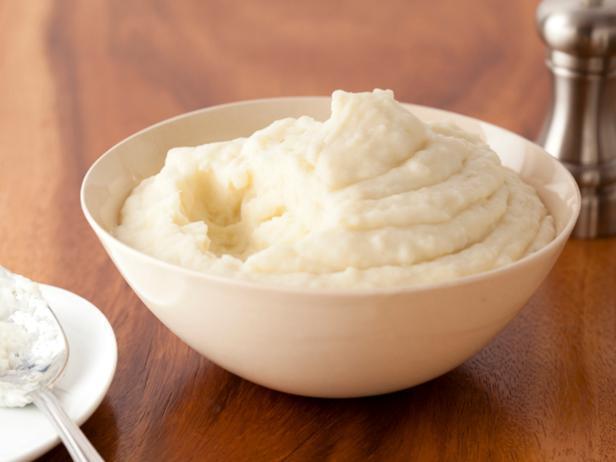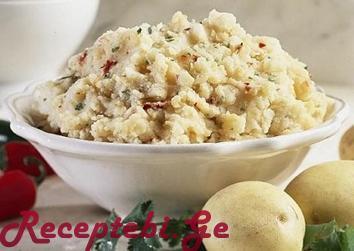The first image is the image on the left, the second image is the image on the right. Considering the images on both sides, is "At least one image in the set features a green garnish on top of the food and other dishes in the background." valid? Answer yes or no. No. The first image is the image on the left, the second image is the image on the right. Given the left and right images, does the statement "A silverware serving utensil is in one image with a bowl of mashed potatoes." hold true? Answer yes or no. Yes. 